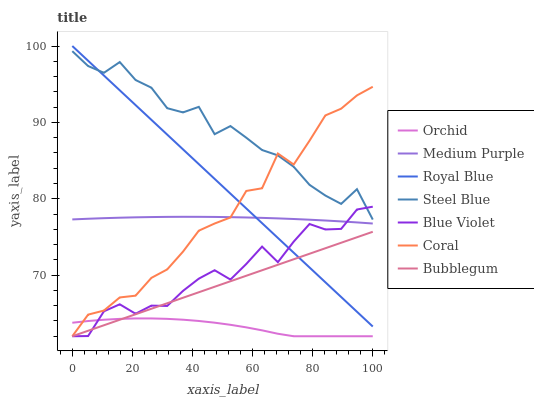Does Orchid have the minimum area under the curve?
Answer yes or no. Yes. Does Steel Blue have the maximum area under the curve?
Answer yes or no. Yes. Does Bubblegum have the minimum area under the curve?
Answer yes or no. No. Does Bubblegum have the maximum area under the curve?
Answer yes or no. No. Is Bubblegum the smoothest?
Answer yes or no. Yes. Is Steel Blue the roughest?
Answer yes or no. Yes. Is Steel Blue the smoothest?
Answer yes or no. No. Is Bubblegum the roughest?
Answer yes or no. No. Does Coral have the lowest value?
Answer yes or no. Yes. Does Steel Blue have the lowest value?
Answer yes or no. No. Does Royal Blue have the highest value?
Answer yes or no. Yes. Does Steel Blue have the highest value?
Answer yes or no. No. Is Bubblegum less than Medium Purple?
Answer yes or no. Yes. Is Medium Purple greater than Orchid?
Answer yes or no. Yes. Does Coral intersect Orchid?
Answer yes or no. Yes. Is Coral less than Orchid?
Answer yes or no. No. Is Coral greater than Orchid?
Answer yes or no. No. Does Bubblegum intersect Medium Purple?
Answer yes or no. No. 